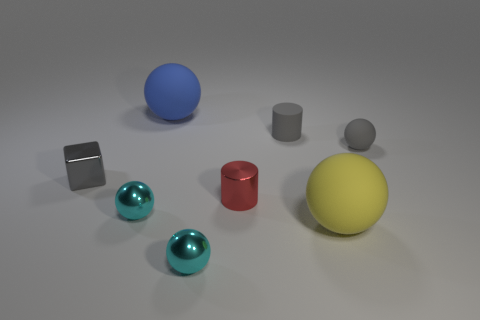What can you say about the arrangement of the objects? The objects are spread out across the surface in a somewhat random pattern. There are variations in height and color among the objects, which creates a diverse and visually interesting composition. The contrasting colors and shapes draw attention to the individual characteristics of each item. Do you think there's any significance to their placement? Without additional context, it's hard to ascribe significance to the exact placement of the objects. It could be a simple aesthetic arrangement, an exercise in understanding three-dimensional forms, or a setup for demonstrating principles of lighting and shadow. The arrangement invites contemplation and might represent an artistic or educational purpose. 